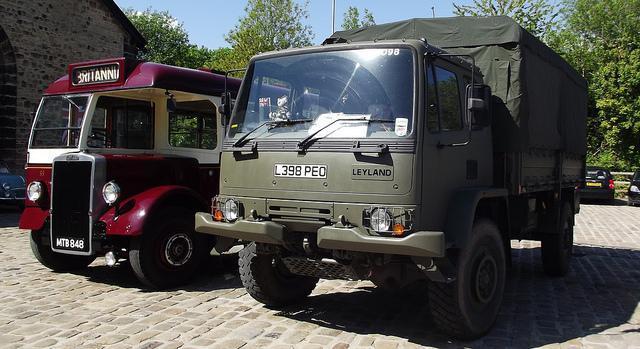How many buses are there?
Give a very brief answer. 1. How many women are wearing a black coat?
Give a very brief answer. 0. 